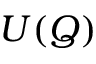<formula> <loc_0><loc_0><loc_500><loc_500>U ( \boldsymbol Q )</formula> 